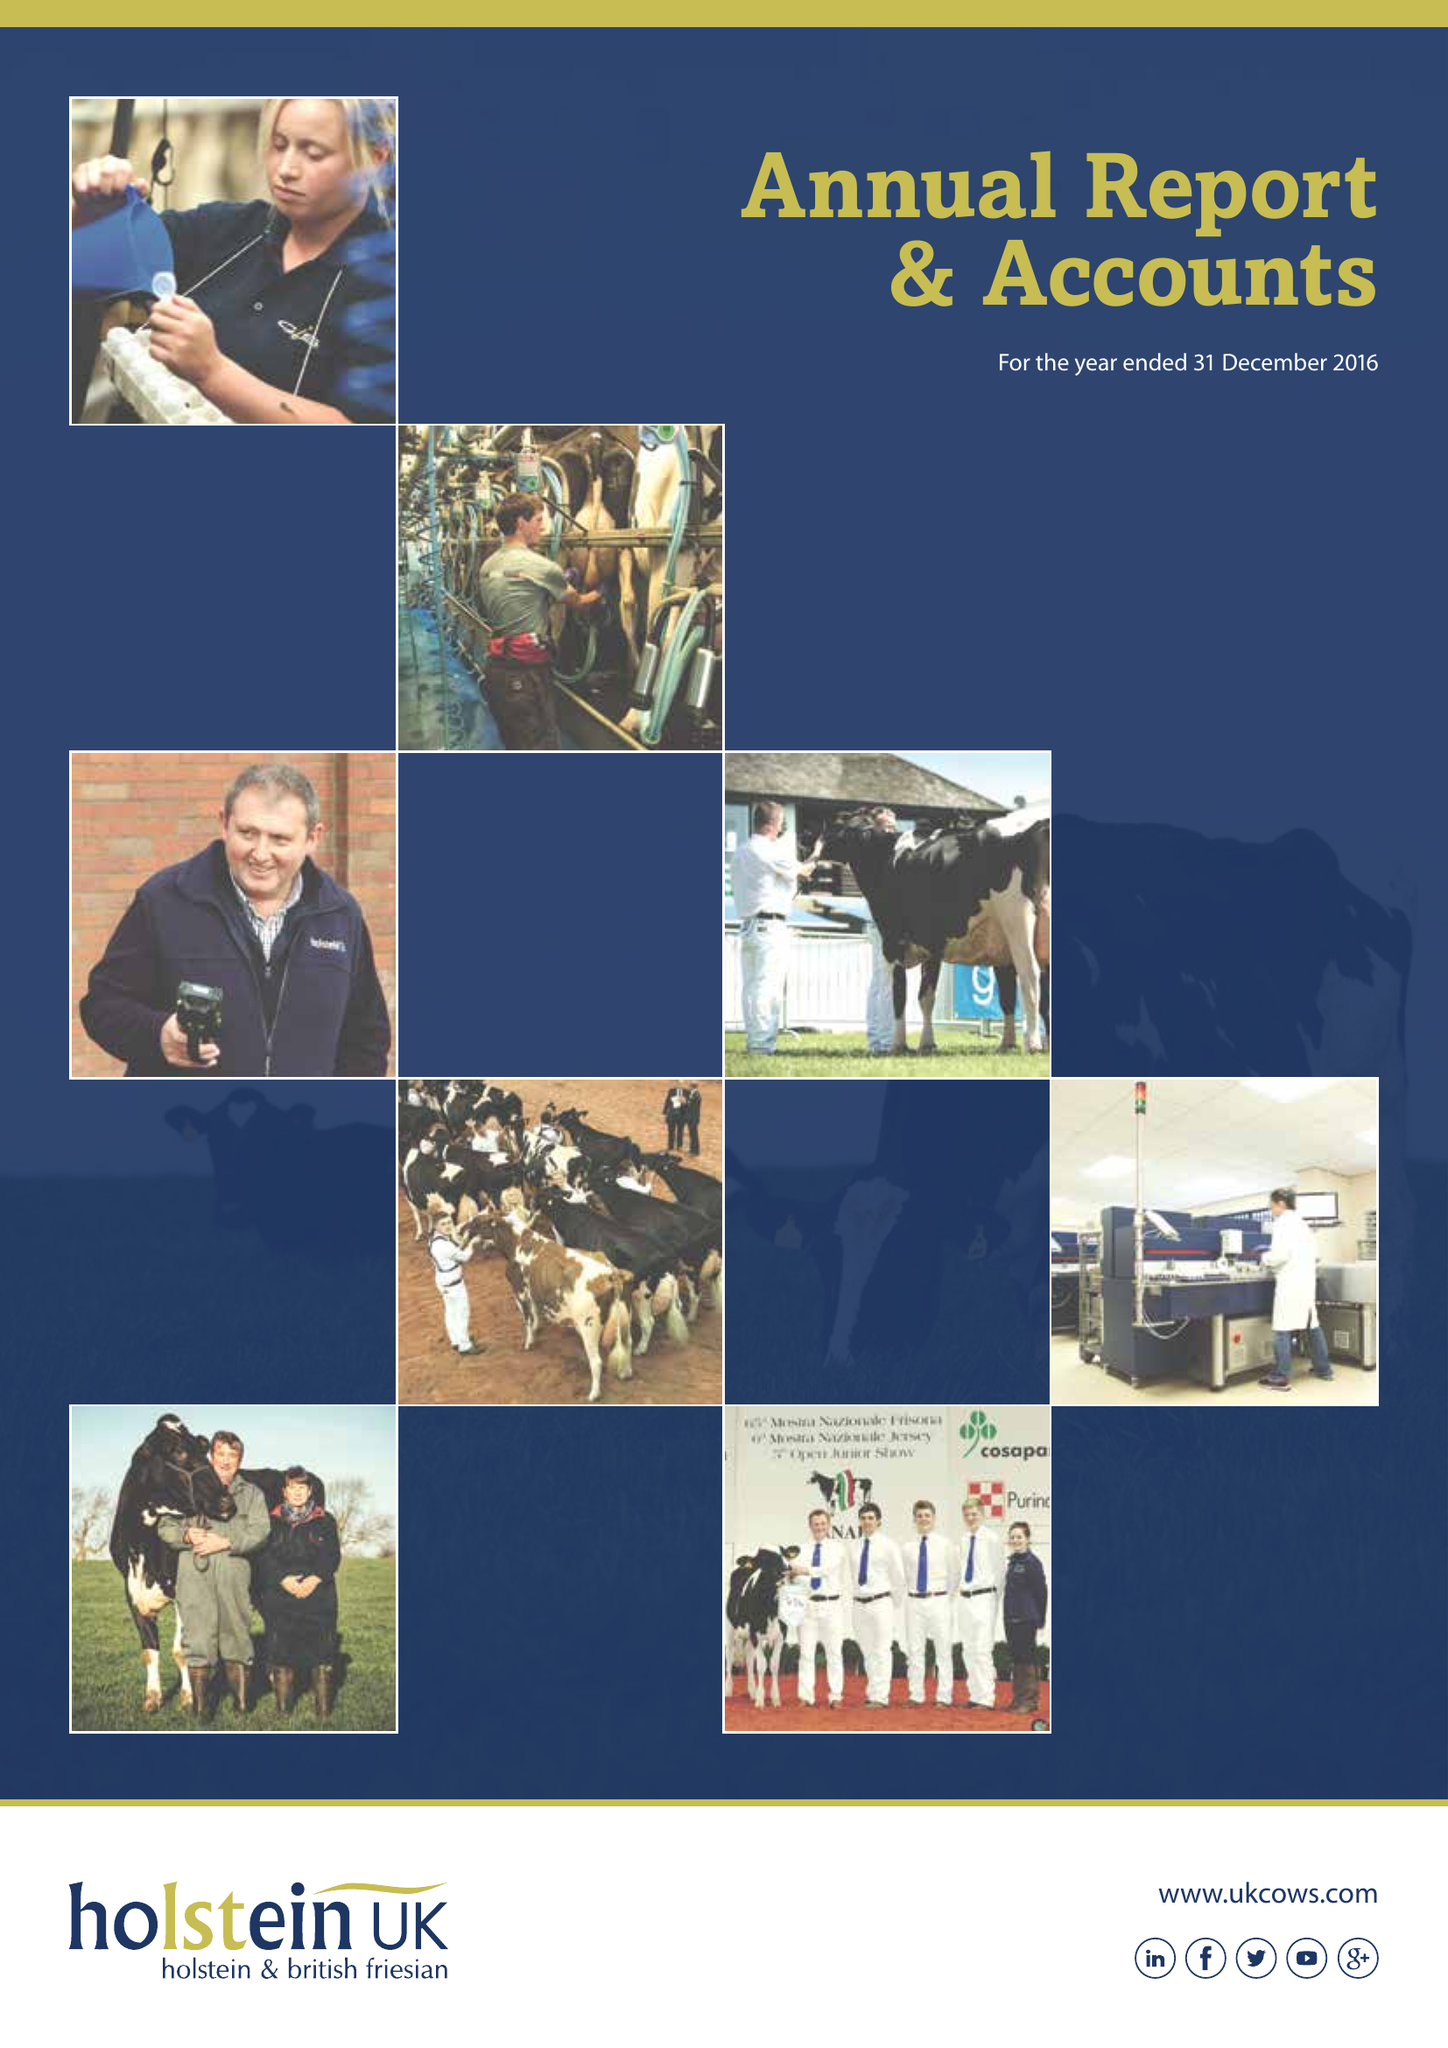What is the value for the charity_number?
Answer the question using a single word or phrase. 1072998 